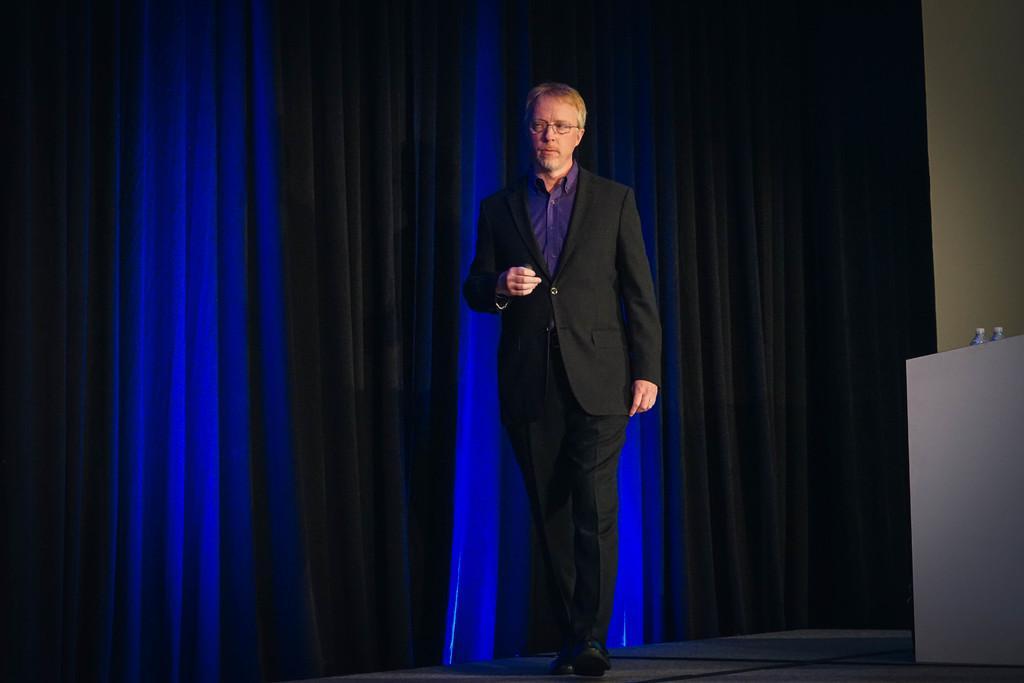How would you summarize this image in a sentence or two? This picture shows a man standing on the dais and he wore spectacles on his face and we see curtains on the back and couple of water bottles on the table. 